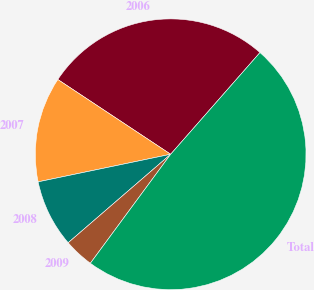Convert chart to OTSL. <chart><loc_0><loc_0><loc_500><loc_500><pie_chart><fcel>2006<fcel>2007<fcel>2008<fcel>2009<fcel>Total<nl><fcel>27.16%<fcel>12.58%<fcel>8.07%<fcel>3.56%<fcel>48.64%<nl></chart> 